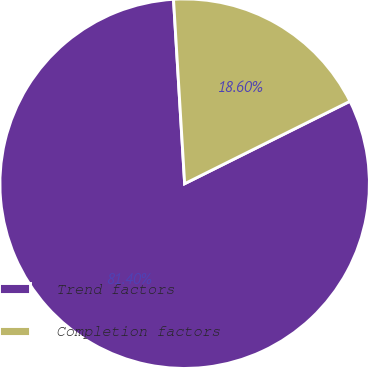Convert chart to OTSL. <chart><loc_0><loc_0><loc_500><loc_500><pie_chart><fcel>Trend factors<fcel>Completion factors<nl><fcel>81.4%<fcel>18.6%<nl></chart> 